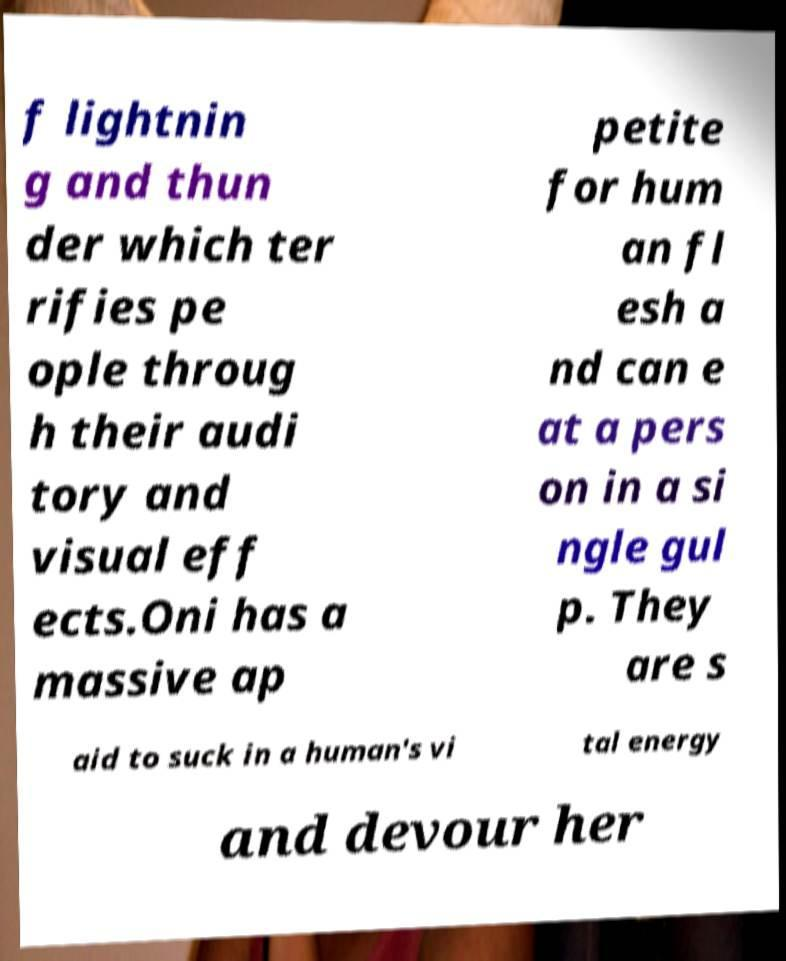What messages or text are displayed in this image? I need them in a readable, typed format. f lightnin g and thun der which ter rifies pe ople throug h their audi tory and visual eff ects.Oni has a massive ap petite for hum an fl esh a nd can e at a pers on in a si ngle gul p. They are s aid to suck in a human's vi tal energy and devour her 